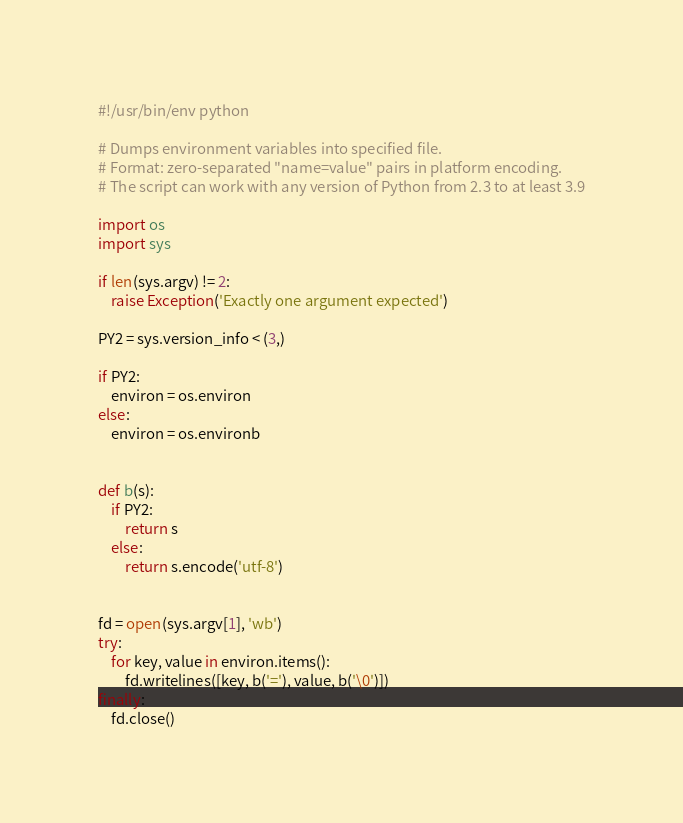<code> <loc_0><loc_0><loc_500><loc_500><_Python_>#!/usr/bin/env python

# Dumps environment variables into specified file.
# Format: zero-separated "name=value" pairs in platform encoding.
# The script can work with any version of Python from 2.3 to at least 3.9

import os
import sys

if len(sys.argv) != 2:
    raise Exception('Exactly one argument expected')

PY2 = sys.version_info < (3,)

if PY2:
    environ = os.environ
else:
    environ = os.environb


def b(s):
    if PY2:
        return s
    else:
        return s.encode('utf-8')


fd = open(sys.argv[1], 'wb')
try:
    for key, value in environ.items():
        fd.writelines([key, b('='), value, b('\0')])
finally:
    fd.close()
</code> 